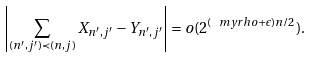<formula> <loc_0><loc_0><loc_500><loc_500>\left | \sum _ { ( n ^ { \prime } , j ^ { \prime } ) \prec ( n , j ) } X _ { n ^ { \prime } , j ^ { \prime } } - Y _ { n ^ { \prime } , j ^ { \prime } } \right | = o ( 2 ^ { ( \ m y r h o + \epsilon ) n / 2 } ) .</formula> 